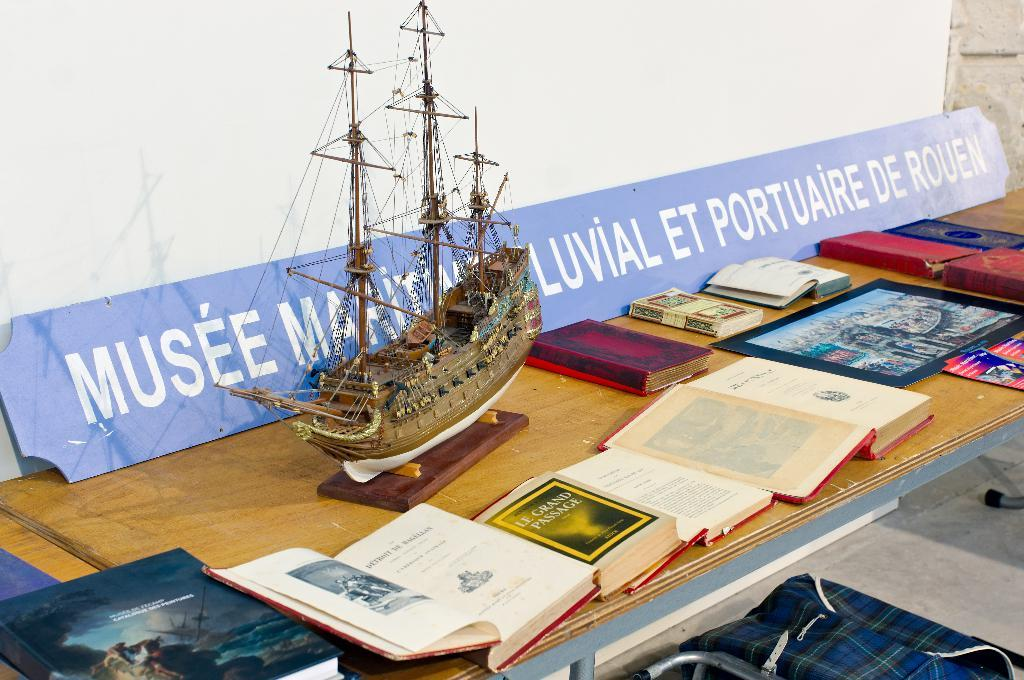<image>
Summarize the visual content of the image. A scale model of a boat sits in front of a sign that reads Musee Maritime Luvial Et Portuaire De Rouen. 